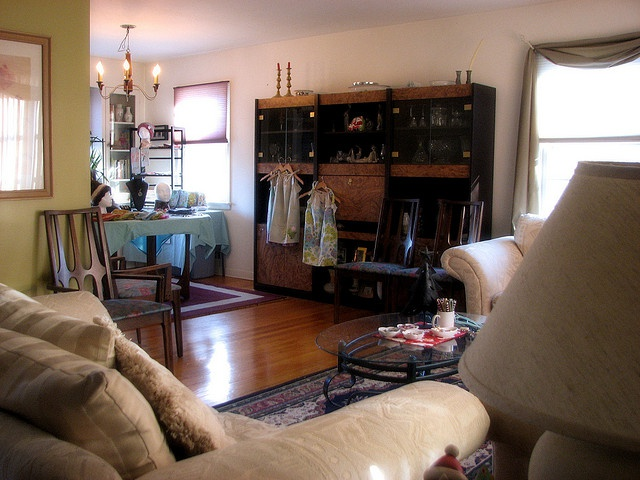Describe the objects in this image and their specific colors. I can see couch in brown, black, tan, and maroon tones, chair in brown, black, maroon, and gray tones, dining table in brown, gray, and black tones, couch in brown, lavender, gray, darkgray, and tan tones, and chair in brown, black, navy, gray, and darkblue tones in this image. 